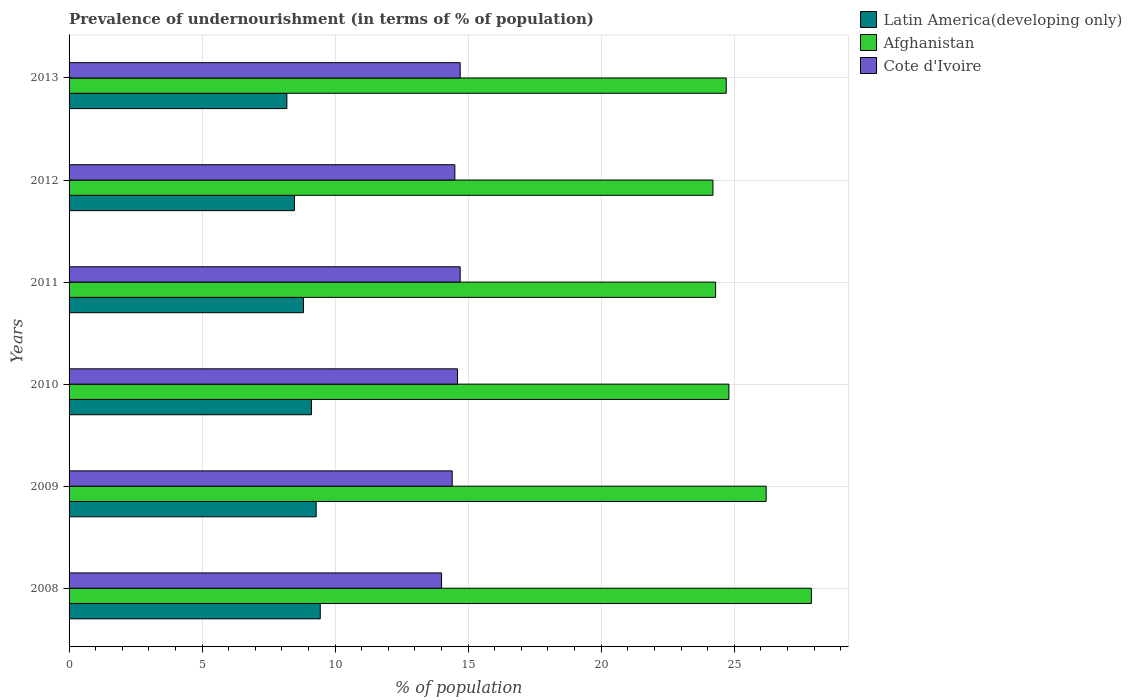How many groups of bars are there?
Give a very brief answer. 6. Are the number of bars per tick equal to the number of legend labels?
Keep it short and to the point. Yes. How many bars are there on the 1st tick from the bottom?
Ensure brevity in your answer.  3. In how many cases, is the number of bars for a given year not equal to the number of legend labels?
Offer a terse response. 0. What is the percentage of undernourished population in Afghanistan in 2011?
Provide a succinct answer. 24.3. Across all years, what is the minimum percentage of undernourished population in Afghanistan?
Offer a terse response. 24.2. What is the total percentage of undernourished population in Afghanistan in the graph?
Your answer should be very brief. 152.1. What is the difference between the percentage of undernourished population in Latin America(developing only) in 2009 and that in 2012?
Offer a terse response. 0.82. What is the difference between the percentage of undernourished population in Cote d'Ivoire in 2008 and the percentage of undernourished population in Latin America(developing only) in 2013?
Ensure brevity in your answer.  5.81. What is the average percentage of undernourished population in Afghanistan per year?
Offer a terse response. 25.35. In the year 2013, what is the difference between the percentage of undernourished population in Cote d'Ivoire and percentage of undernourished population in Latin America(developing only)?
Keep it short and to the point. 6.51. What is the ratio of the percentage of undernourished population in Latin America(developing only) in 2010 to that in 2013?
Make the answer very short. 1.11. What is the difference between the highest and the lowest percentage of undernourished population in Cote d'Ivoire?
Your answer should be compact. 0.7. What does the 2nd bar from the top in 2011 represents?
Your response must be concise. Afghanistan. What does the 3rd bar from the bottom in 2012 represents?
Ensure brevity in your answer.  Cote d'Ivoire. Is it the case that in every year, the sum of the percentage of undernourished population in Cote d'Ivoire and percentage of undernourished population in Afghanistan is greater than the percentage of undernourished population in Latin America(developing only)?
Offer a very short reply. Yes. Are all the bars in the graph horizontal?
Provide a succinct answer. Yes. Are the values on the major ticks of X-axis written in scientific E-notation?
Your answer should be compact. No. Does the graph contain grids?
Your answer should be very brief. Yes. How many legend labels are there?
Offer a very short reply. 3. What is the title of the graph?
Make the answer very short. Prevalence of undernourishment (in terms of % of population). Does "Least developed countries" appear as one of the legend labels in the graph?
Keep it short and to the point. No. What is the label or title of the X-axis?
Your answer should be compact. % of population. What is the % of population in Latin America(developing only) in 2008?
Ensure brevity in your answer.  9.44. What is the % of population of Afghanistan in 2008?
Provide a short and direct response. 27.9. What is the % of population in Latin America(developing only) in 2009?
Offer a very short reply. 9.29. What is the % of population in Afghanistan in 2009?
Make the answer very short. 26.2. What is the % of population in Latin America(developing only) in 2010?
Provide a succinct answer. 9.11. What is the % of population of Afghanistan in 2010?
Offer a very short reply. 24.8. What is the % of population in Cote d'Ivoire in 2010?
Keep it short and to the point. 14.6. What is the % of population of Latin America(developing only) in 2011?
Your answer should be compact. 8.81. What is the % of population in Afghanistan in 2011?
Offer a terse response. 24.3. What is the % of population in Cote d'Ivoire in 2011?
Your answer should be compact. 14.7. What is the % of population of Latin America(developing only) in 2012?
Offer a terse response. 8.47. What is the % of population in Afghanistan in 2012?
Offer a very short reply. 24.2. What is the % of population in Latin America(developing only) in 2013?
Offer a terse response. 8.19. What is the % of population of Afghanistan in 2013?
Your answer should be very brief. 24.7. What is the % of population of Cote d'Ivoire in 2013?
Keep it short and to the point. 14.7. Across all years, what is the maximum % of population of Latin America(developing only)?
Give a very brief answer. 9.44. Across all years, what is the maximum % of population of Afghanistan?
Give a very brief answer. 27.9. Across all years, what is the maximum % of population of Cote d'Ivoire?
Give a very brief answer. 14.7. Across all years, what is the minimum % of population in Latin America(developing only)?
Your answer should be compact. 8.19. Across all years, what is the minimum % of population of Afghanistan?
Offer a terse response. 24.2. What is the total % of population of Latin America(developing only) in the graph?
Provide a short and direct response. 53.31. What is the total % of population of Afghanistan in the graph?
Offer a terse response. 152.1. What is the total % of population of Cote d'Ivoire in the graph?
Your answer should be compact. 86.9. What is the difference between the % of population in Latin America(developing only) in 2008 and that in 2009?
Your answer should be very brief. 0.15. What is the difference between the % of population in Afghanistan in 2008 and that in 2009?
Provide a succinct answer. 1.7. What is the difference between the % of population of Latin America(developing only) in 2008 and that in 2010?
Provide a succinct answer. 0.33. What is the difference between the % of population in Afghanistan in 2008 and that in 2010?
Ensure brevity in your answer.  3.1. What is the difference between the % of population in Latin America(developing only) in 2008 and that in 2011?
Provide a succinct answer. 0.63. What is the difference between the % of population of Afghanistan in 2008 and that in 2011?
Offer a very short reply. 3.6. What is the difference between the % of population of Latin America(developing only) in 2008 and that in 2012?
Offer a terse response. 0.97. What is the difference between the % of population in Latin America(developing only) in 2008 and that in 2013?
Provide a succinct answer. 1.25. What is the difference between the % of population in Afghanistan in 2008 and that in 2013?
Make the answer very short. 3.2. What is the difference between the % of population in Latin America(developing only) in 2009 and that in 2010?
Provide a succinct answer. 0.18. What is the difference between the % of population of Cote d'Ivoire in 2009 and that in 2010?
Keep it short and to the point. -0.2. What is the difference between the % of population of Latin America(developing only) in 2009 and that in 2011?
Your answer should be very brief. 0.48. What is the difference between the % of population in Afghanistan in 2009 and that in 2011?
Your answer should be very brief. 1.9. What is the difference between the % of population of Latin America(developing only) in 2009 and that in 2012?
Provide a short and direct response. 0.82. What is the difference between the % of population of Afghanistan in 2009 and that in 2012?
Offer a terse response. 2. What is the difference between the % of population in Latin America(developing only) in 2009 and that in 2013?
Your answer should be very brief. 1.1. What is the difference between the % of population of Latin America(developing only) in 2010 and that in 2011?
Provide a short and direct response. 0.3. What is the difference between the % of population of Afghanistan in 2010 and that in 2011?
Your answer should be compact. 0.5. What is the difference between the % of population of Cote d'Ivoire in 2010 and that in 2011?
Give a very brief answer. -0.1. What is the difference between the % of population in Latin America(developing only) in 2010 and that in 2012?
Keep it short and to the point. 0.64. What is the difference between the % of population of Afghanistan in 2010 and that in 2012?
Provide a succinct answer. 0.6. What is the difference between the % of population of Latin America(developing only) in 2010 and that in 2013?
Offer a very short reply. 0.92. What is the difference between the % of population of Afghanistan in 2010 and that in 2013?
Your answer should be very brief. 0.1. What is the difference between the % of population in Latin America(developing only) in 2011 and that in 2012?
Provide a succinct answer. 0.34. What is the difference between the % of population of Latin America(developing only) in 2011 and that in 2013?
Offer a very short reply. 0.62. What is the difference between the % of population of Cote d'Ivoire in 2011 and that in 2013?
Your answer should be compact. 0. What is the difference between the % of population in Latin America(developing only) in 2012 and that in 2013?
Make the answer very short. 0.29. What is the difference between the % of population in Afghanistan in 2012 and that in 2013?
Provide a short and direct response. -0.5. What is the difference between the % of population of Cote d'Ivoire in 2012 and that in 2013?
Provide a short and direct response. -0.2. What is the difference between the % of population of Latin America(developing only) in 2008 and the % of population of Afghanistan in 2009?
Give a very brief answer. -16.76. What is the difference between the % of population in Latin America(developing only) in 2008 and the % of population in Cote d'Ivoire in 2009?
Make the answer very short. -4.96. What is the difference between the % of population in Latin America(developing only) in 2008 and the % of population in Afghanistan in 2010?
Provide a succinct answer. -15.36. What is the difference between the % of population of Latin America(developing only) in 2008 and the % of population of Cote d'Ivoire in 2010?
Give a very brief answer. -5.16. What is the difference between the % of population in Afghanistan in 2008 and the % of population in Cote d'Ivoire in 2010?
Your response must be concise. 13.3. What is the difference between the % of population in Latin America(developing only) in 2008 and the % of population in Afghanistan in 2011?
Your answer should be very brief. -14.86. What is the difference between the % of population in Latin America(developing only) in 2008 and the % of population in Cote d'Ivoire in 2011?
Your response must be concise. -5.26. What is the difference between the % of population in Afghanistan in 2008 and the % of population in Cote d'Ivoire in 2011?
Make the answer very short. 13.2. What is the difference between the % of population of Latin America(developing only) in 2008 and the % of population of Afghanistan in 2012?
Your answer should be very brief. -14.76. What is the difference between the % of population in Latin America(developing only) in 2008 and the % of population in Cote d'Ivoire in 2012?
Your answer should be very brief. -5.06. What is the difference between the % of population in Latin America(developing only) in 2008 and the % of population in Afghanistan in 2013?
Offer a terse response. -15.26. What is the difference between the % of population of Latin America(developing only) in 2008 and the % of population of Cote d'Ivoire in 2013?
Make the answer very short. -5.26. What is the difference between the % of population in Latin America(developing only) in 2009 and the % of population in Afghanistan in 2010?
Your response must be concise. -15.51. What is the difference between the % of population of Latin America(developing only) in 2009 and the % of population of Cote d'Ivoire in 2010?
Provide a short and direct response. -5.31. What is the difference between the % of population of Latin America(developing only) in 2009 and the % of population of Afghanistan in 2011?
Keep it short and to the point. -15.01. What is the difference between the % of population in Latin America(developing only) in 2009 and the % of population in Cote d'Ivoire in 2011?
Provide a succinct answer. -5.41. What is the difference between the % of population of Afghanistan in 2009 and the % of population of Cote d'Ivoire in 2011?
Make the answer very short. 11.5. What is the difference between the % of population of Latin America(developing only) in 2009 and the % of population of Afghanistan in 2012?
Ensure brevity in your answer.  -14.91. What is the difference between the % of population in Latin America(developing only) in 2009 and the % of population in Cote d'Ivoire in 2012?
Make the answer very short. -5.21. What is the difference between the % of population of Afghanistan in 2009 and the % of population of Cote d'Ivoire in 2012?
Offer a terse response. 11.7. What is the difference between the % of population of Latin America(developing only) in 2009 and the % of population of Afghanistan in 2013?
Provide a succinct answer. -15.41. What is the difference between the % of population in Latin America(developing only) in 2009 and the % of population in Cote d'Ivoire in 2013?
Provide a short and direct response. -5.41. What is the difference between the % of population in Latin America(developing only) in 2010 and the % of population in Afghanistan in 2011?
Your answer should be very brief. -15.19. What is the difference between the % of population of Latin America(developing only) in 2010 and the % of population of Cote d'Ivoire in 2011?
Offer a very short reply. -5.59. What is the difference between the % of population in Afghanistan in 2010 and the % of population in Cote d'Ivoire in 2011?
Your response must be concise. 10.1. What is the difference between the % of population of Latin America(developing only) in 2010 and the % of population of Afghanistan in 2012?
Provide a succinct answer. -15.09. What is the difference between the % of population in Latin America(developing only) in 2010 and the % of population in Cote d'Ivoire in 2012?
Ensure brevity in your answer.  -5.39. What is the difference between the % of population in Afghanistan in 2010 and the % of population in Cote d'Ivoire in 2012?
Make the answer very short. 10.3. What is the difference between the % of population of Latin America(developing only) in 2010 and the % of population of Afghanistan in 2013?
Ensure brevity in your answer.  -15.59. What is the difference between the % of population of Latin America(developing only) in 2010 and the % of population of Cote d'Ivoire in 2013?
Offer a very short reply. -5.59. What is the difference between the % of population of Afghanistan in 2010 and the % of population of Cote d'Ivoire in 2013?
Provide a short and direct response. 10.1. What is the difference between the % of population in Latin America(developing only) in 2011 and the % of population in Afghanistan in 2012?
Ensure brevity in your answer.  -15.39. What is the difference between the % of population of Latin America(developing only) in 2011 and the % of population of Cote d'Ivoire in 2012?
Your response must be concise. -5.69. What is the difference between the % of population of Latin America(developing only) in 2011 and the % of population of Afghanistan in 2013?
Provide a succinct answer. -15.89. What is the difference between the % of population of Latin America(developing only) in 2011 and the % of population of Cote d'Ivoire in 2013?
Make the answer very short. -5.89. What is the difference between the % of population of Afghanistan in 2011 and the % of population of Cote d'Ivoire in 2013?
Make the answer very short. 9.6. What is the difference between the % of population in Latin America(developing only) in 2012 and the % of population in Afghanistan in 2013?
Provide a succinct answer. -16.23. What is the difference between the % of population in Latin America(developing only) in 2012 and the % of population in Cote d'Ivoire in 2013?
Offer a very short reply. -6.23. What is the average % of population in Latin America(developing only) per year?
Offer a terse response. 8.88. What is the average % of population in Afghanistan per year?
Keep it short and to the point. 25.35. What is the average % of population in Cote d'Ivoire per year?
Make the answer very short. 14.48. In the year 2008, what is the difference between the % of population in Latin America(developing only) and % of population in Afghanistan?
Give a very brief answer. -18.46. In the year 2008, what is the difference between the % of population of Latin America(developing only) and % of population of Cote d'Ivoire?
Your answer should be very brief. -4.56. In the year 2008, what is the difference between the % of population in Afghanistan and % of population in Cote d'Ivoire?
Keep it short and to the point. 13.9. In the year 2009, what is the difference between the % of population of Latin America(developing only) and % of population of Afghanistan?
Offer a terse response. -16.91. In the year 2009, what is the difference between the % of population in Latin America(developing only) and % of population in Cote d'Ivoire?
Provide a short and direct response. -5.11. In the year 2009, what is the difference between the % of population in Afghanistan and % of population in Cote d'Ivoire?
Keep it short and to the point. 11.8. In the year 2010, what is the difference between the % of population in Latin America(developing only) and % of population in Afghanistan?
Offer a terse response. -15.69. In the year 2010, what is the difference between the % of population of Latin America(developing only) and % of population of Cote d'Ivoire?
Offer a very short reply. -5.49. In the year 2011, what is the difference between the % of population of Latin America(developing only) and % of population of Afghanistan?
Make the answer very short. -15.49. In the year 2011, what is the difference between the % of population in Latin America(developing only) and % of population in Cote d'Ivoire?
Offer a terse response. -5.89. In the year 2012, what is the difference between the % of population in Latin America(developing only) and % of population in Afghanistan?
Give a very brief answer. -15.73. In the year 2012, what is the difference between the % of population of Latin America(developing only) and % of population of Cote d'Ivoire?
Provide a short and direct response. -6.03. In the year 2013, what is the difference between the % of population of Latin America(developing only) and % of population of Afghanistan?
Give a very brief answer. -16.51. In the year 2013, what is the difference between the % of population in Latin America(developing only) and % of population in Cote d'Ivoire?
Provide a short and direct response. -6.51. In the year 2013, what is the difference between the % of population of Afghanistan and % of population of Cote d'Ivoire?
Your answer should be very brief. 10. What is the ratio of the % of population in Latin America(developing only) in 2008 to that in 2009?
Ensure brevity in your answer.  1.02. What is the ratio of the % of population of Afghanistan in 2008 to that in 2009?
Provide a short and direct response. 1.06. What is the ratio of the % of population of Cote d'Ivoire in 2008 to that in 2009?
Keep it short and to the point. 0.97. What is the ratio of the % of population of Latin America(developing only) in 2008 to that in 2010?
Ensure brevity in your answer.  1.04. What is the ratio of the % of population in Cote d'Ivoire in 2008 to that in 2010?
Give a very brief answer. 0.96. What is the ratio of the % of population of Latin America(developing only) in 2008 to that in 2011?
Keep it short and to the point. 1.07. What is the ratio of the % of population in Afghanistan in 2008 to that in 2011?
Your answer should be very brief. 1.15. What is the ratio of the % of population of Cote d'Ivoire in 2008 to that in 2011?
Keep it short and to the point. 0.95. What is the ratio of the % of population in Latin America(developing only) in 2008 to that in 2012?
Give a very brief answer. 1.11. What is the ratio of the % of population of Afghanistan in 2008 to that in 2012?
Offer a very short reply. 1.15. What is the ratio of the % of population in Cote d'Ivoire in 2008 to that in 2012?
Make the answer very short. 0.97. What is the ratio of the % of population of Latin America(developing only) in 2008 to that in 2013?
Give a very brief answer. 1.15. What is the ratio of the % of population of Afghanistan in 2008 to that in 2013?
Your answer should be very brief. 1.13. What is the ratio of the % of population of Cote d'Ivoire in 2008 to that in 2013?
Keep it short and to the point. 0.95. What is the ratio of the % of population in Latin America(developing only) in 2009 to that in 2010?
Provide a succinct answer. 1.02. What is the ratio of the % of population of Afghanistan in 2009 to that in 2010?
Your answer should be very brief. 1.06. What is the ratio of the % of population of Cote d'Ivoire in 2009 to that in 2010?
Keep it short and to the point. 0.99. What is the ratio of the % of population in Latin America(developing only) in 2009 to that in 2011?
Offer a terse response. 1.05. What is the ratio of the % of population of Afghanistan in 2009 to that in 2011?
Provide a succinct answer. 1.08. What is the ratio of the % of population of Cote d'Ivoire in 2009 to that in 2011?
Give a very brief answer. 0.98. What is the ratio of the % of population of Latin America(developing only) in 2009 to that in 2012?
Provide a succinct answer. 1.1. What is the ratio of the % of population of Afghanistan in 2009 to that in 2012?
Offer a terse response. 1.08. What is the ratio of the % of population of Cote d'Ivoire in 2009 to that in 2012?
Ensure brevity in your answer.  0.99. What is the ratio of the % of population in Latin America(developing only) in 2009 to that in 2013?
Offer a very short reply. 1.13. What is the ratio of the % of population of Afghanistan in 2009 to that in 2013?
Keep it short and to the point. 1.06. What is the ratio of the % of population of Cote d'Ivoire in 2009 to that in 2013?
Your response must be concise. 0.98. What is the ratio of the % of population of Latin America(developing only) in 2010 to that in 2011?
Make the answer very short. 1.03. What is the ratio of the % of population in Afghanistan in 2010 to that in 2011?
Your answer should be very brief. 1.02. What is the ratio of the % of population of Latin America(developing only) in 2010 to that in 2012?
Ensure brevity in your answer.  1.08. What is the ratio of the % of population in Afghanistan in 2010 to that in 2012?
Provide a succinct answer. 1.02. What is the ratio of the % of population in Cote d'Ivoire in 2010 to that in 2012?
Offer a terse response. 1.01. What is the ratio of the % of population of Latin America(developing only) in 2010 to that in 2013?
Your response must be concise. 1.11. What is the ratio of the % of population of Afghanistan in 2010 to that in 2013?
Keep it short and to the point. 1. What is the ratio of the % of population of Latin America(developing only) in 2011 to that in 2012?
Offer a very short reply. 1.04. What is the ratio of the % of population in Cote d'Ivoire in 2011 to that in 2012?
Provide a succinct answer. 1.01. What is the ratio of the % of population in Latin America(developing only) in 2011 to that in 2013?
Keep it short and to the point. 1.08. What is the ratio of the % of population of Afghanistan in 2011 to that in 2013?
Ensure brevity in your answer.  0.98. What is the ratio of the % of population in Cote d'Ivoire in 2011 to that in 2013?
Keep it short and to the point. 1. What is the ratio of the % of population in Latin America(developing only) in 2012 to that in 2013?
Ensure brevity in your answer.  1.03. What is the ratio of the % of population in Afghanistan in 2012 to that in 2013?
Ensure brevity in your answer.  0.98. What is the ratio of the % of population in Cote d'Ivoire in 2012 to that in 2013?
Ensure brevity in your answer.  0.99. What is the difference between the highest and the second highest % of population in Latin America(developing only)?
Keep it short and to the point. 0.15. What is the difference between the highest and the second highest % of population in Cote d'Ivoire?
Make the answer very short. 0. What is the difference between the highest and the lowest % of population of Latin America(developing only)?
Offer a terse response. 1.25. 